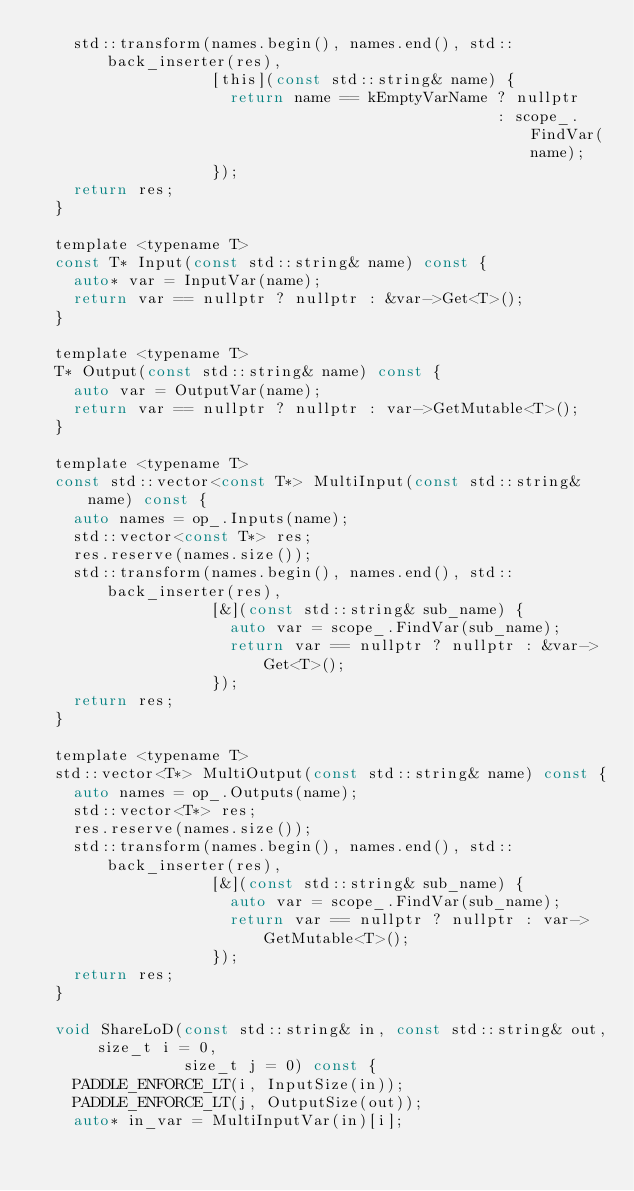<code> <loc_0><loc_0><loc_500><loc_500><_C_>    std::transform(names.begin(), names.end(), std::back_inserter(res),
                   [this](const std::string& name) {
                     return name == kEmptyVarName ? nullptr
                                                  : scope_.FindVar(name);
                   });
    return res;
  }

  template <typename T>
  const T* Input(const std::string& name) const {
    auto* var = InputVar(name);
    return var == nullptr ? nullptr : &var->Get<T>();
  }

  template <typename T>
  T* Output(const std::string& name) const {
    auto var = OutputVar(name);
    return var == nullptr ? nullptr : var->GetMutable<T>();
  }

  template <typename T>
  const std::vector<const T*> MultiInput(const std::string& name) const {
    auto names = op_.Inputs(name);
    std::vector<const T*> res;
    res.reserve(names.size());
    std::transform(names.begin(), names.end(), std::back_inserter(res),
                   [&](const std::string& sub_name) {
                     auto var = scope_.FindVar(sub_name);
                     return var == nullptr ? nullptr : &var->Get<T>();
                   });
    return res;
  }

  template <typename T>
  std::vector<T*> MultiOutput(const std::string& name) const {
    auto names = op_.Outputs(name);
    std::vector<T*> res;
    res.reserve(names.size());
    std::transform(names.begin(), names.end(), std::back_inserter(res),
                   [&](const std::string& sub_name) {
                     auto var = scope_.FindVar(sub_name);
                     return var == nullptr ? nullptr : var->GetMutable<T>();
                   });
    return res;
  }

  void ShareLoD(const std::string& in, const std::string& out, size_t i = 0,
                size_t j = 0) const {
    PADDLE_ENFORCE_LT(i, InputSize(in));
    PADDLE_ENFORCE_LT(j, OutputSize(out));
    auto* in_var = MultiInputVar(in)[i];</code> 